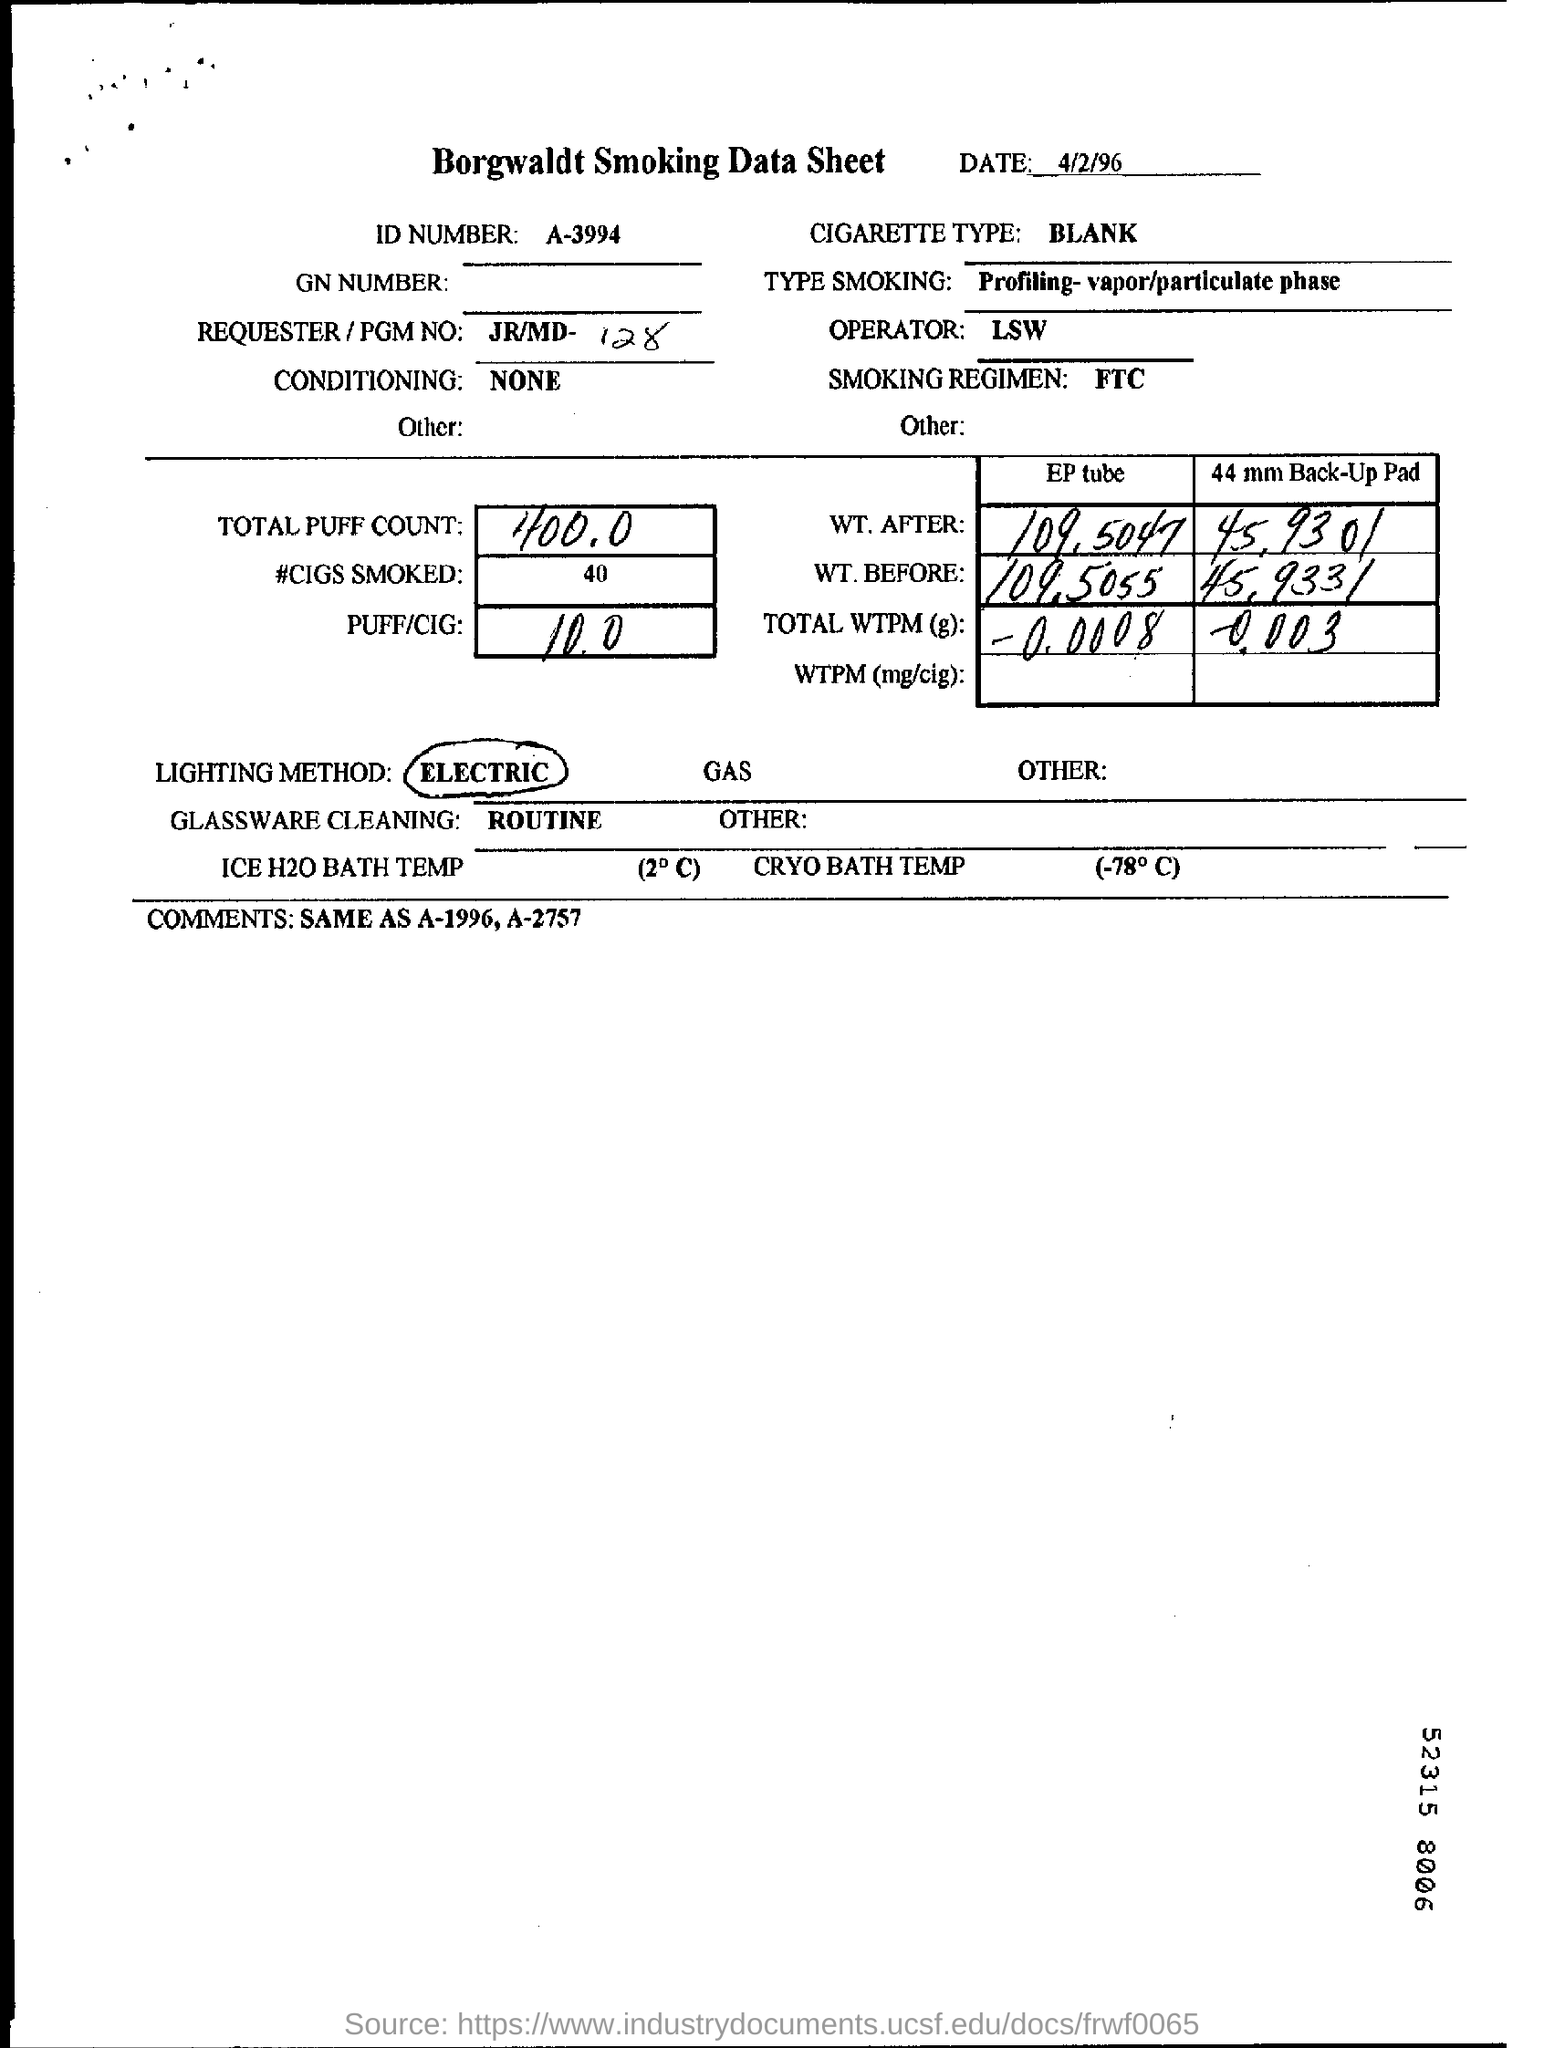What is the Title of the document ?
Give a very brief answer. Borgwaldt Smoking Data Sheet. What is the date mentioned in the top of the document ?
Make the answer very short. 4/2/96. What is the ID Number written in the document ?
Keep it short and to the point. A-3994. What is written in the Cigarette Type Field ?
Make the answer very short. BLANK. What is mentioned in the Operator Field ?
Your answer should be very brief. LSW. What is written in the Type Smoking Field ?
Offer a very short reply. Profiling-vapor/particulate phase. What type of Conditioning is applied ?
Give a very brief answer. NONE. What is written in the Smoking Regimen Field ?
Your answer should be compact. FTC. 